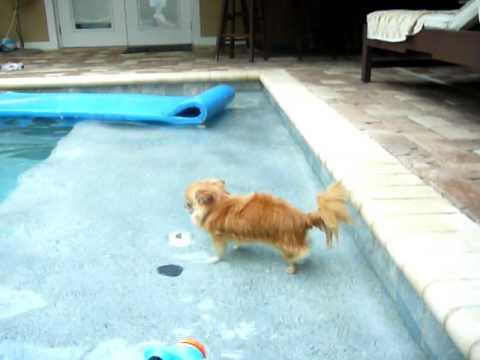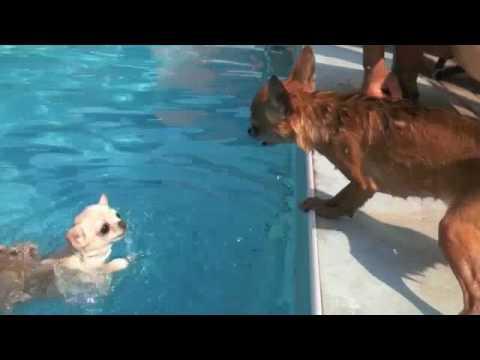The first image is the image on the left, the second image is the image on the right. For the images shown, is this caption "There are two dogs in the pictures." true? Answer yes or no. No. 